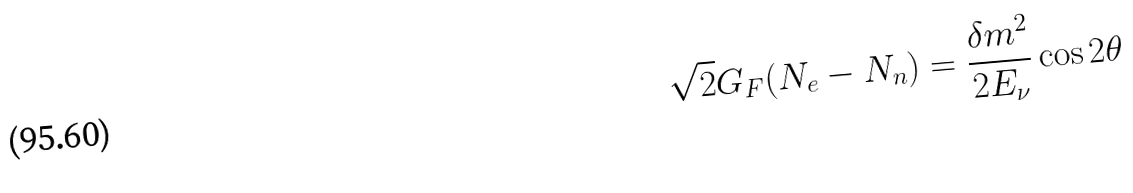<formula> <loc_0><loc_0><loc_500><loc_500>\sqrt { 2 } G _ { F } ( N _ { e } - N _ { n } ) = \frac { \delta m ^ { 2 } } { 2 E _ { \nu } } \cos 2 \theta</formula> 